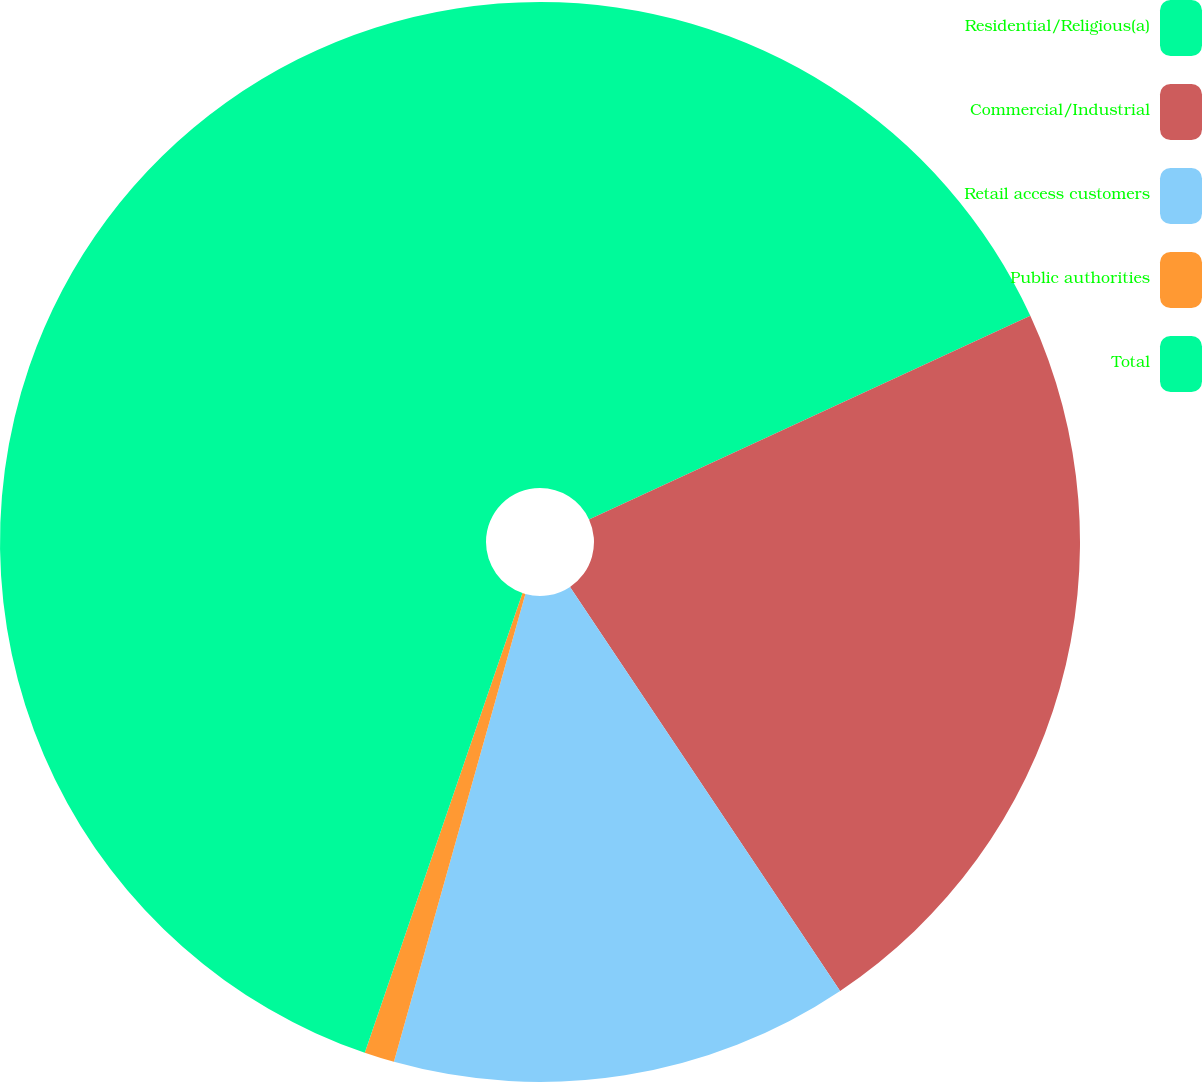Convert chart to OTSL. <chart><loc_0><loc_0><loc_500><loc_500><pie_chart><fcel>Residential/Religious(a)<fcel>Commercial/Industrial<fcel>Retail access customers<fcel>Public authorities<fcel>Total<nl><fcel>18.12%<fcel>22.5%<fcel>13.74%<fcel>0.9%<fcel>44.74%<nl></chart> 